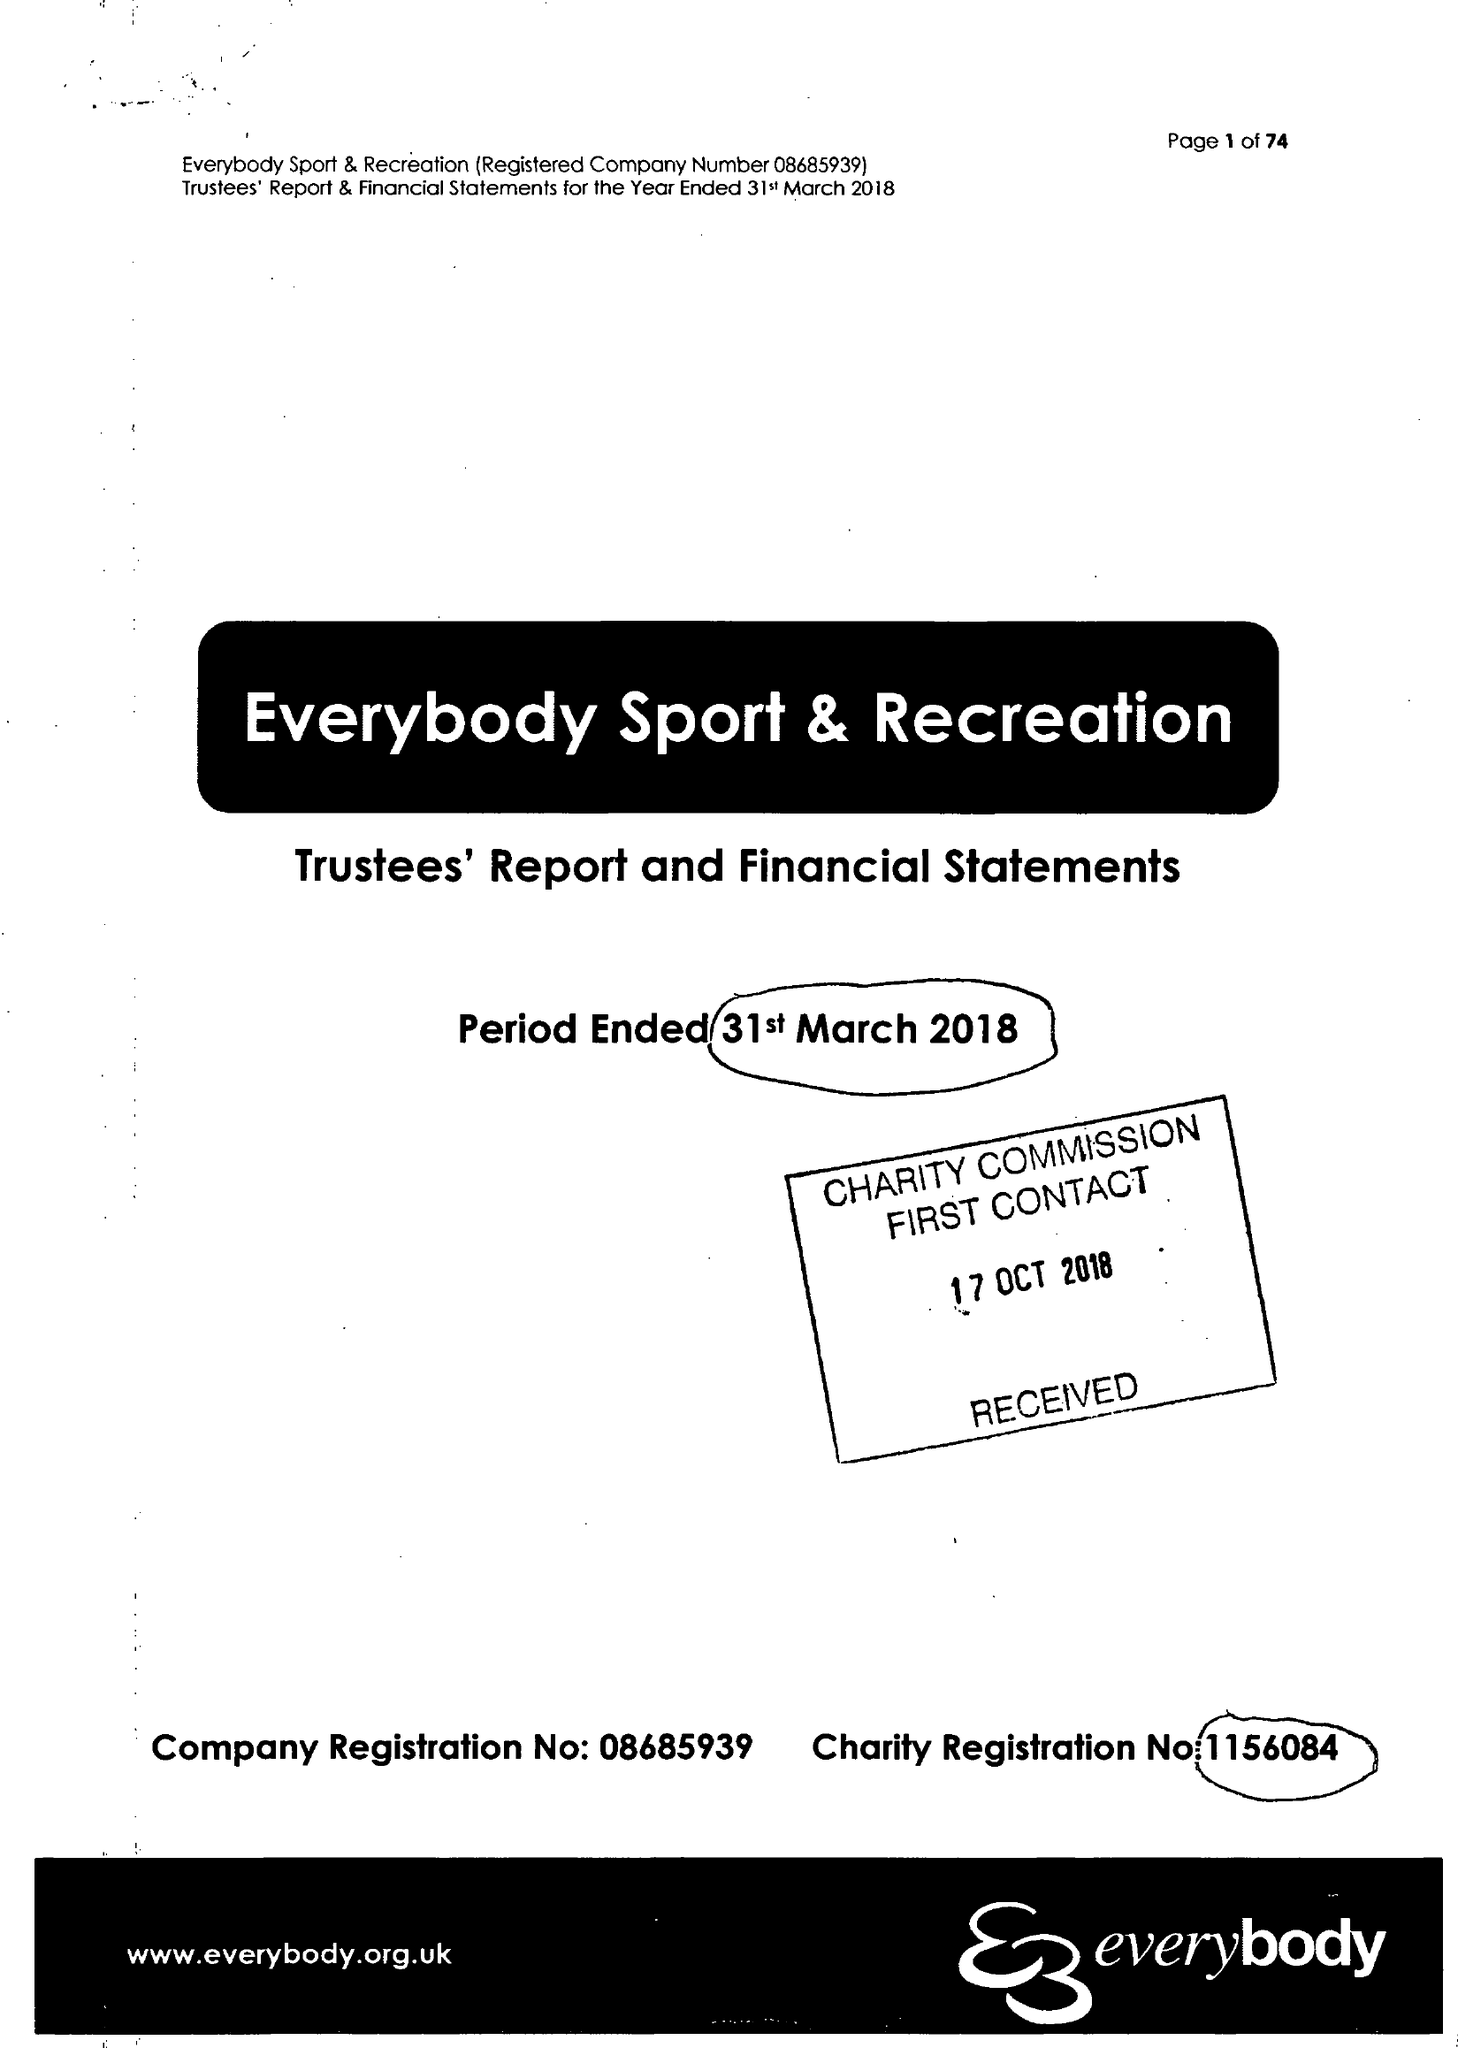What is the value for the address__street_line?
Answer the question using a single word or phrase. STATION ROAD 